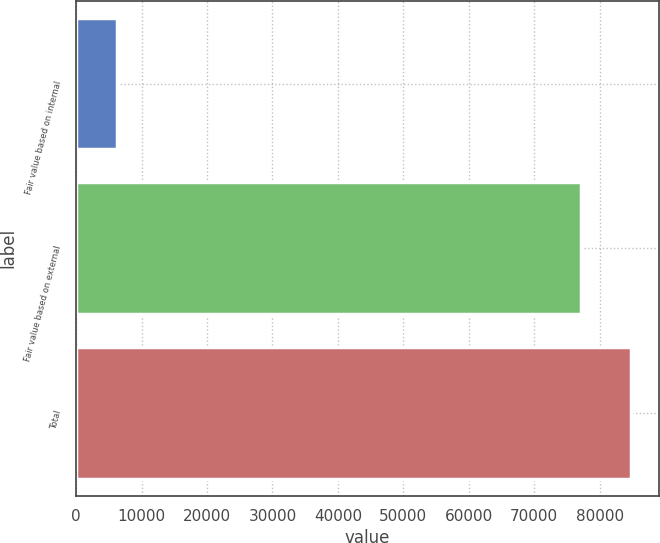<chart> <loc_0><loc_0><loc_500><loc_500><bar_chart><fcel>Fair value based on internal<fcel>Fair value based on external<fcel>Total<nl><fcel>6277<fcel>77113<fcel>84824.3<nl></chart> 